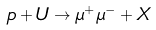<formula> <loc_0><loc_0><loc_500><loc_500>p + U \to \mu ^ { + } \mu ^ { - } + X</formula> 